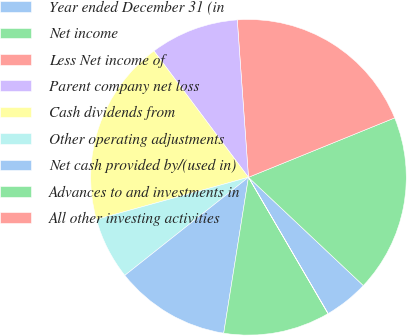<chart> <loc_0><loc_0><loc_500><loc_500><pie_chart><fcel>Year ended December 31 (in<fcel>Net income<fcel>Less Net income of<fcel>Parent company net loss<fcel>Cash dividends from<fcel>Other operating adjustments<fcel>Net cash provided by/(used in)<fcel>Advances to and investments in<fcel>All other investing activities<nl><fcel>4.55%<fcel>18.17%<fcel>19.99%<fcel>9.09%<fcel>19.08%<fcel>6.37%<fcel>11.82%<fcel>10.91%<fcel>0.02%<nl></chart> 